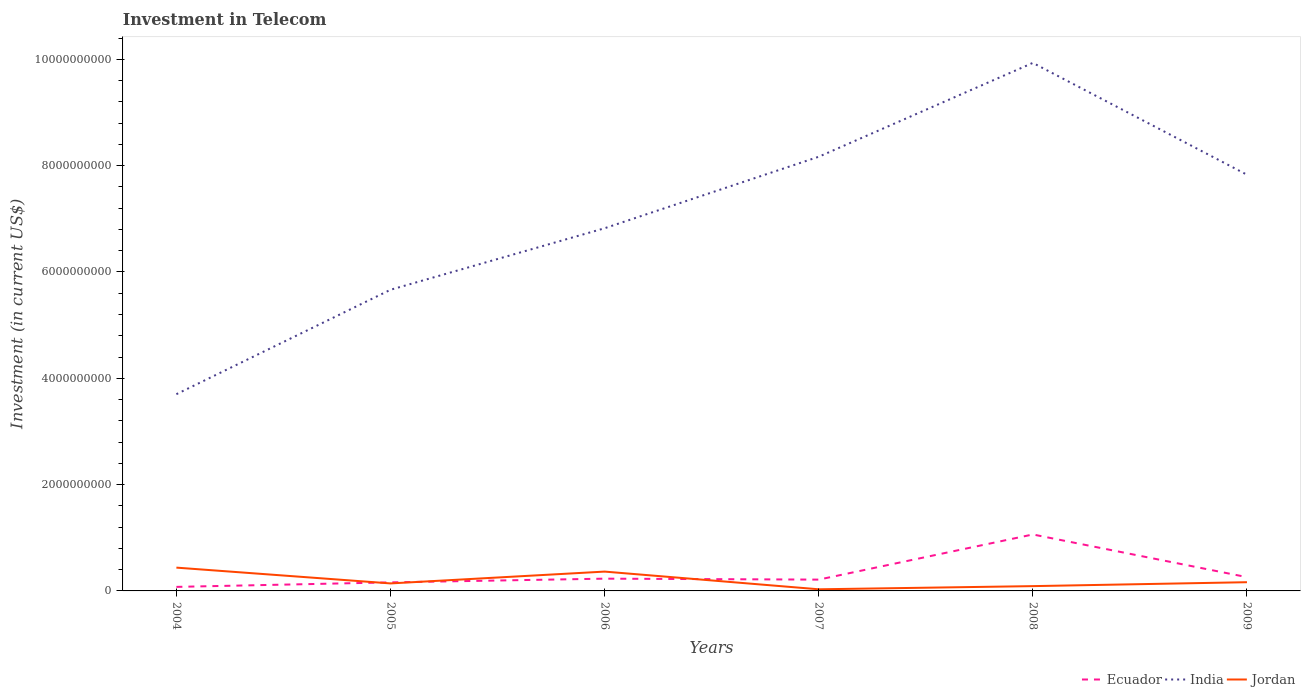How many different coloured lines are there?
Your response must be concise. 3. Is the number of lines equal to the number of legend labels?
Your answer should be very brief. Yes. Across all years, what is the maximum amount invested in telecom in Ecuador?
Make the answer very short. 7.59e+07. What is the total amount invested in telecom in Jordan in the graph?
Give a very brief answer. -7.37e+07. What is the difference between the highest and the second highest amount invested in telecom in India?
Give a very brief answer. 6.23e+09. What is the difference between the highest and the lowest amount invested in telecom in India?
Offer a very short reply. 3. How many lines are there?
Your answer should be very brief. 3. Does the graph contain any zero values?
Your response must be concise. No. How many legend labels are there?
Make the answer very short. 3. How are the legend labels stacked?
Provide a succinct answer. Horizontal. What is the title of the graph?
Offer a terse response. Investment in Telecom. What is the label or title of the X-axis?
Your answer should be compact. Years. What is the label or title of the Y-axis?
Your answer should be compact. Investment (in current US$). What is the Investment (in current US$) in Ecuador in 2004?
Offer a terse response. 7.59e+07. What is the Investment (in current US$) in India in 2004?
Your response must be concise. 3.70e+09. What is the Investment (in current US$) of Jordan in 2004?
Keep it short and to the point. 4.38e+08. What is the Investment (in current US$) of Ecuador in 2005?
Ensure brevity in your answer.  1.61e+08. What is the Investment (in current US$) in India in 2005?
Your response must be concise. 5.67e+09. What is the Investment (in current US$) of Jordan in 2005?
Make the answer very short. 1.41e+08. What is the Investment (in current US$) of Ecuador in 2006?
Offer a terse response. 2.31e+08. What is the Investment (in current US$) in India in 2006?
Ensure brevity in your answer.  6.82e+09. What is the Investment (in current US$) of Jordan in 2006?
Offer a very short reply. 3.64e+08. What is the Investment (in current US$) of Ecuador in 2007?
Your answer should be compact. 2.13e+08. What is the Investment (in current US$) in India in 2007?
Your answer should be very brief. 8.17e+09. What is the Investment (in current US$) of Jordan in 2007?
Make the answer very short. 3.07e+07. What is the Investment (in current US$) in Ecuador in 2008?
Ensure brevity in your answer.  1.06e+09. What is the Investment (in current US$) of India in 2008?
Offer a very short reply. 9.93e+09. What is the Investment (in current US$) of Jordan in 2008?
Provide a succinct answer. 9.03e+07. What is the Investment (in current US$) of Ecuador in 2009?
Keep it short and to the point. 2.59e+08. What is the Investment (in current US$) of India in 2009?
Provide a short and direct response. 7.83e+09. What is the Investment (in current US$) of Jordan in 2009?
Provide a succinct answer. 1.64e+08. Across all years, what is the maximum Investment (in current US$) in Ecuador?
Your answer should be compact. 1.06e+09. Across all years, what is the maximum Investment (in current US$) in India?
Keep it short and to the point. 9.93e+09. Across all years, what is the maximum Investment (in current US$) of Jordan?
Give a very brief answer. 4.38e+08. Across all years, what is the minimum Investment (in current US$) of Ecuador?
Keep it short and to the point. 7.59e+07. Across all years, what is the minimum Investment (in current US$) of India?
Provide a short and direct response. 3.70e+09. Across all years, what is the minimum Investment (in current US$) in Jordan?
Offer a terse response. 3.07e+07. What is the total Investment (in current US$) of Ecuador in the graph?
Your answer should be very brief. 2.00e+09. What is the total Investment (in current US$) of India in the graph?
Offer a very short reply. 4.21e+1. What is the total Investment (in current US$) of Jordan in the graph?
Provide a succinct answer. 1.23e+09. What is the difference between the Investment (in current US$) of Ecuador in 2004 and that in 2005?
Give a very brief answer. -8.49e+07. What is the difference between the Investment (in current US$) in India in 2004 and that in 2005?
Make the answer very short. -1.96e+09. What is the difference between the Investment (in current US$) in Jordan in 2004 and that in 2005?
Your answer should be very brief. 2.97e+08. What is the difference between the Investment (in current US$) of Ecuador in 2004 and that in 2006?
Give a very brief answer. -1.55e+08. What is the difference between the Investment (in current US$) of India in 2004 and that in 2006?
Offer a very short reply. -3.12e+09. What is the difference between the Investment (in current US$) in Jordan in 2004 and that in 2006?
Offer a very short reply. 7.47e+07. What is the difference between the Investment (in current US$) in Ecuador in 2004 and that in 2007?
Your answer should be compact. -1.37e+08. What is the difference between the Investment (in current US$) in India in 2004 and that in 2007?
Your answer should be compact. -4.47e+09. What is the difference between the Investment (in current US$) in Jordan in 2004 and that in 2007?
Your response must be concise. 4.08e+08. What is the difference between the Investment (in current US$) of Ecuador in 2004 and that in 2008?
Your response must be concise. -9.86e+08. What is the difference between the Investment (in current US$) in India in 2004 and that in 2008?
Your response must be concise. -6.23e+09. What is the difference between the Investment (in current US$) of Jordan in 2004 and that in 2008?
Provide a short and direct response. 3.48e+08. What is the difference between the Investment (in current US$) in Ecuador in 2004 and that in 2009?
Ensure brevity in your answer.  -1.83e+08. What is the difference between the Investment (in current US$) in India in 2004 and that in 2009?
Make the answer very short. -4.13e+09. What is the difference between the Investment (in current US$) of Jordan in 2004 and that in 2009?
Provide a succinct answer. 2.74e+08. What is the difference between the Investment (in current US$) in Ecuador in 2005 and that in 2006?
Ensure brevity in your answer.  -7.00e+07. What is the difference between the Investment (in current US$) of India in 2005 and that in 2006?
Your response must be concise. -1.16e+09. What is the difference between the Investment (in current US$) of Jordan in 2005 and that in 2006?
Give a very brief answer. -2.23e+08. What is the difference between the Investment (in current US$) in Ecuador in 2005 and that in 2007?
Give a very brief answer. -5.19e+07. What is the difference between the Investment (in current US$) in India in 2005 and that in 2007?
Give a very brief answer. -2.50e+09. What is the difference between the Investment (in current US$) in Jordan in 2005 and that in 2007?
Your answer should be very brief. 1.10e+08. What is the difference between the Investment (in current US$) in Ecuador in 2005 and that in 2008?
Provide a short and direct response. -9.01e+08. What is the difference between the Investment (in current US$) of India in 2005 and that in 2008?
Offer a terse response. -4.27e+09. What is the difference between the Investment (in current US$) in Jordan in 2005 and that in 2008?
Offer a terse response. 5.07e+07. What is the difference between the Investment (in current US$) in Ecuador in 2005 and that in 2009?
Offer a very short reply. -9.83e+07. What is the difference between the Investment (in current US$) of India in 2005 and that in 2009?
Your answer should be very brief. -2.16e+09. What is the difference between the Investment (in current US$) of Jordan in 2005 and that in 2009?
Give a very brief answer. -2.30e+07. What is the difference between the Investment (in current US$) of Ecuador in 2006 and that in 2007?
Provide a short and direct response. 1.81e+07. What is the difference between the Investment (in current US$) of India in 2006 and that in 2007?
Keep it short and to the point. -1.35e+09. What is the difference between the Investment (in current US$) of Jordan in 2006 and that in 2007?
Provide a short and direct response. 3.33e+08. What is the difference between the Investment (in current US$) in Ecuador in 2006 and that in 2008?
Make the answer very short. -8.31e+08. What is the difference between the Investment (in current US$) of India in 2006 and that in 2008?
Provide a short and direct response. -3.11e+09. What is the difference between the Investment (in current US$) in Jordan in 2006 and that in 2008?
Your answer should be compact. 2.73e+08. What is the difference between the Investment (in current US$) in Ecuador in 2006 and that in 2009?
Provide a succinct answer. -2.83e+07. What is the difference between the Investment (in current US$) in India in 2006 and that in 2009?
Your answer should be compact. -1.01e+09. What is the difference between the Investment (in current US$) of Jordan in 2006 and that in 2009?
Offer a very short reply. 2.00e+08. What is the difference between the Investment (in current US$) of Ecuador in 2007 and that in 2008?
Your answer should be very brief. -8.49e+08. What is the difference between the Investment (in current US$) of India in 2007 and that in 2008?
Offer a very short reply. -1.77e+09. What is the difference between the Investment (in current US$) of Jordan in 2007 and that in 2008?
Offer a very short reply. -5.96e+07. What is the difference between the Investment (in current US$) in Ecuador in 2007 and that in 2009?
Ensure brevity in your answer.  -4.64e+07. What is the difference between the Investment (in current US$) in India in 2007 and that in 2009?
Ensure brevity in your answer.  3.38e+08. What is the difference between the Investment (in current US$) in Jordan in 2007 and that in 2009?
Your response must be concise. -1.33e+08. What is the difference between the Investment (in current US$) in Ecuador in 2008 and that in 2009?
Make the answer very short. 8.03e+08. What is the difference between the Investment (in current US$) in India in 2008 and that in 2009?
Offer a very short reply. 2.10e+09. What is the difference between the Investment (in current US$) of Jordan in 2008 and that in 2009?
Make the answer very short. -7.37e+07. What is the difference between the Investment (in current US$) in Ecuador in 2004 and the Investment (in current US$) in India in 2005?
Offer a terse response. -5.59e+09. What is the difference between the Investment (in current US$) of Ecuador in 2004 and the Investment (in current US$) of Jordan in 2005?
Make the answer very short. -6.51e+07. What is the difference between the Investment (in current US$) in India in 2004 and the Investment (in current US$) in Jordan in 2005?
Provide a short and direct response. 3.56e+09. What is the difference between the Investment (in current US$) of Ecuador in 2004 and the Investment (in current US$) of India in 2006?
Your answer should be very brief. -6.75e+09. What is the difference between the Investment (in current US$) of Ecuador in 2004 and the Investment (in current US$) of Jordan in 2006?
Keep it short and to the point. -2.88e+08. What is the difference between the Investment (in current US$) in India in 2004 and the Investment (in current US$) in Jordan in 2006?
Provide a succinct answer. 3.34e+09. What is the difference between the Investment (in current US$) of Ecuador in 2004 and the Investment (in current US$) of India in 2007?
Make the answer very short. -8.09e+09. What is the difference between the Investment (in current US$) of Ecuador in 2004 and the Investment (in current US$) of Jordan in 2007?
Your response must be concise. 4.52e+07. What is the difference between the Investment (in current US$) of India in 2004 and the Investment (in current US$) of Jordan in 2007?
Ensure brevity in your answer.  3.67e+09. What is the difference between the Investment (in current US$) of Ecuador in 2004 and the Investment (in current US$) of India in 2008?
Your answer should be very brief. -9.86e+09. What is the difference between the Investment (in current US$) in Ecuador in 2004 and the Investment (in current US$) in Jordan in 2008?
Provide a short and direct response. -1.44e+07. What is the difference between the Investment (in current US$) in India in 2004 and the Investment (in current US$) in Jordan in 2008?
Keep it short and to the point. 3.61e+09. What is the difference between the Investment (in current US$) in Ecuador in 2004 and the Investment (in current US$) in India in 2009?
Provide a succinct answer. -7.75e+09. What is the difference between the Investment (in current US$) in Ecuador in 2004 and the Investment (in current US$) in Jordan in 2009?
Your response must be concise. -8.81e+07. What is the difference between the Investment (in current US$) of India in 2004 and the Investment (in current US$) of Jordan in 2009?
Your answer should be very brief. 3.54e+09. What is the difference between the Investment (in current US$) in Ecuador in 2005 and the Investment (in current US$) in India in 2006?
Offer a terse response. -6.66e+09. What is the difference between the Investment (in current US$) in Ecuador in 2005 and the Investment (in current US$) in Jordan in 2006?
Provide a short and direct response. -2.03e+08. What is the difference between the Investment (in current US$) of India in 2005 and the Investment (in current US$) of Jordan in 2006?
Provide a succinct answer. 5.30e+09. What is the difference between the Investment (in current US$) of Ecuador in 2005 and the Investment (in current US$) of India in 2007?
Provide a succinct answer. -8.01e+09. What is the difference between the Investment (in current US$) in Ecuador in 2005 and the Investment (in current US$) in Jordan in 2007?
Ensure brevity in your answer.  1.30e+08. What is the difference between the Investment (in current US$) of India in 2005 and the Investment (in current US$) of Jordan in 2007?
Ensure brevity in your answer.  5.64e+09. What is the difference between the Investment (in current US$) in Ecuador in 2005 and the Investment (in current US$) in India in 2008?
Offer a very short reply. -9.77e+09. What is the difference between the Investment (in current US$) in Ecuador in 2005 and the Investment (in current US$) in Jordan in 2008?
Make the answer very short. 7.05e+07. What is the difference between the Investment (in current US$) in India in 2005 and the Investment (in current US$) in Jordan in 2008?
Provide a short and direct response. 5.58e+09. What is the difference between the Investment (in current US$) of Ecuador in 2005 and the Investment (in current US$) of India in 2009?
Provide a short and direct response. -7.67e+09. What is the difference between the Investment (in current US$) of Ecuador in 2005 and the Investment (in current US$) of Jordan in 2009?
Offer a terse response. -3.20e+06. What is the difference between the Investment (in current US$) in India in 2005 and the Investment (in current US$) in Jordan in 2009?
Offer a very short reply. 5.50e+09. What is the difference between the Investment (in current US$) in Ecuador in 2006 and the Investment (in current US$) in India in 2007?
Provide a succinct answer. -7.94e+09. What is the difference between the Investment (in current US$) of Ecuador in 2006 and the Investment (in current US$) of Jordan in 2007?
Your answer should be compact. 2.00e+08. What is the difference between the Investment (in current US$) in India in 2006 and the Investment (in current US$) in Jordan in 2007?
Your answer should be very brief. 6.79e+09. What is the difference between the Investment (in current US$) in Ecuador in 2006 and the Investment (in current US$) in India in 2008?
Give a very brief answer. -9.70e+09. What is the difference between the Investment (in current US$) in Ecuador in 2006 and the Investment (in current US$) in Jordan in 2008?
Provide a short and direct response. 1.40e+08. What is the difference between the Investment (in current US$) of India in 2006 and the Investment (in current US$) of Jordan in 2008?
Your answer should be compact. 6.73e+09. What is the difference between the Investment (in current US$) of Ecuador in 2006 and the Investment (in current US$) of India in 2009?
Provide a succinct answer. -7.60e+09. What is the difference between the Investment (in current US$) of Ecuador in 2006 and the Investment (in current US$) of Jordan in 2009?
Your response must be concise. 6.68e+07. What is the difference between the Investment (in current US$) of India in 2006 and the Investment (in current US$) of Jordan in 2009?
Give a very brief answer. 6.66e+09. What is the difference between the Investment (in current US$) of Ecuador in 2007 and the Investment (in current US$) of India in 2008?
Offer a very short reply. -9.72e+09. What is the difference between the Investment (in current US$) of Ecuador in 2007 and the Investment (in current US$) of Jordan in 2008?
Offer a very short reply. 1.22e+08. What is the difference between the Investment (in current US$) of India in 2007 and the Investment (in current US$) of Jordan in 2008?
Your answer should be very brief. 8.08e+09. What is the difference between the Investment (in current US$) in Ecuador in 2007 and the Investment (in current US$) in India in 2009?
Your answer should be very brief. -7.62e+09. What is the difference between the Investment (in current US$) of Ecuador in 2007 and the Investment (in current US$) of Jordan in 2009?
Give a very brief answer. 4.87e+07. What is the difference between the Investment (in current US$) of India in 2007 and the Investment (in current US$) of Jordan in 2009?
Offer a terse response. 8.00e+09. What is the difference between the Investment (in current US$) in Ecuador in 2008 and the Investment (in current US$) in India in 2009?
Provide a short and direct response. -6.77e+09. What is the difference between the Investment (in current US$) in Ecuador in 2008 and the Investment (in current US$) in Jordan in 2009?
Provide a succinct answer. 8.98e+08. What is the difference between the Investment (in current US$) of India in 2008 and the Investment (in current US$) of Jordan in 2009?
Keep it short and to the point. 9.77e+09. What is the average Investment (in current US$) in Ecuador per year?
Keep it short and to the point. 3.34e+08. What is the average Investment (in current US$) in India per year?
Your response must be concise. 7.02e+09. What is the average Investment (in current US$) of Jordan per year?
Offer a terse response. 2.05e+08. In the year 2004, what is the difference between the Investment (in current US$) in Ecuador and Investment (in current US$) in India?
Provide a short and direct response. -3.63e+09. In the year 2004, what is the difference between the Investment (in current US$) in Ecuador and Investment (in current US$) in Jordan?
Offer a terse response. -3.62e+08. In the year 2004, what is the difference between the Investment (in current US$) of India and Investment (in current US$) of Jordan?
Your response must be concise. 3.26e+09. In the year 2005, what is the difference between the Investment (in current US$) of Ecuador and Investment (in current US$) of India?
Keep it short and to the point. -5.50e+09. In the year 2005, what is the difference between the Investment (in current US$) of Ecuador and Investment (in current US$) of Jordan?
Provide a short and direct response. 1.98e+07. In the year 2005, what is the difference between the Investment (in current US$) in India and Investment (in current US$) in Jordan?
Provide a succinct answer. 5.52e+09. In the year 2006, what is the difference between the Investment (in current US$) in Ecuador and Investment (in current US$) in India?
Ensure brevity in your answer.  -6.59e+09. In the year 2006, what is the difference between the Investment (in current US$) of Ecuador and Investment (in current US$) of Jordan?
Ensure brevity in your answer.  -1.33e+08. In the year 2006, what is the difference between the Investment (in current US$) of India and Investment (in current US$) of Jordan?
Keep it short and to the point. 6.46e+09. In the year 2007, what is the difference between the Investment (in current US$) in Ecuador and Investment (in current US$) in India?
Your answer should be very brief. -7.96e+09. In the year 2007, what is the difference between the Investment (in current US$) in Ecuador and Investment (in current US$) in Jordan?
Offer a terse response. 1.82e+08. In the year 2007, what is the difference between the Investment (in current US$) in India and Investment (in current US$) in Jordan?
Offer a very short reply. 8.14e+09. In the year 2008, what is the difference between the Investment (in current US$) in Ecuador and Investment (in current US$) in India?
Offer a terse response. -8.87e+09. In the year 2008, what is the difference between the Investment (in current US$) of Ecuador and Investment (in current US$) of Jordan?
Your response must be concise. 9.72e+08. In the year 2008, what is the difference between the Investment (in current US$) in India and Investment (in current US$) in Jordan?
Keep it short and to the point. 9.84e+09. In the year 2009, what is the difference between the Investment (in current US$) in Ecuador and Investment (in current US$) in India?
Offer a very short reply. -7.57e+09. In the year 2009, what is the difference between the Investment (in current US$) in Ecuador and Investment (in current US$) in Jordan?
Offer a terse response. 9.51e+07. In the year 2009, what is the difference between the Investment (in current US$) of India and Investment (in current US$) of Jordan?
Ensure brevity in your answer.  7.67e+09. What is the ratio of the Investment (in current US$) of Ecuador in 2004 to that in 2005?
Provide a succinct answer. 0.47. What is the ratio of the Investment (in current US$) of India in 2004 to that in 2005?
Ensure brevity in your answer.  0.65. What is the ratio of the Investment (in current US$) of Jordan in 2004 to that in 2005?
Provide a succinct answer. 3.11. What is the ratio of the Investment (in current US$) in Ecuador in 2004 to that in 2006?
Provide a short and direct response. 0.33. What is the ratio of the Investment (in current US$) in India in 2004 to that in 2006?
Offer a terse response. 0.54. What is the ratio of the Investment (in current US$) in Jordan in 2004 to that in 2006?
Your answer should be very brief. 1.21. What is the ratio of the Investment (in current US$) of Ecuador in 2004 to that in 2007?
Keep it short and to the point. 0.36. What is the ratio of the Investment (in current US$) in India in 2004 to that in 2007?
Your answer should be compact. 0.45. What is the ratio of the Investment (in current US$) of Jordan in 2004 to that in 2007?
Provide a short and direct response. 14.28. What is the ratio of the Investment (in current US$) of Ecuador in 2004 to that in 2008?
Keep it short and to the point. 0.07. What is the ratio of the Investment (in current US$) of India in 2004 to that in 2008?
Give a very brief answer. 0.37. What is the ratio of the Investment (in current US$) in Jordan in 2004 to that in 2008?
Your answer should be very brief. 4.85. What is the ratio of the Investment (in current US$) in Ecuador in 2004 to that in 2009?
Offer a terse response. 0.29. What is the ratio of the Investment (in current US$) in India in 2004 to that in 2009?
Offer a terse response. 0.47. What is the ratio of the Investment (in current US$) of Jordan in 2004 to that in 2009?
Give a very brief answer. 2.67. What is the ratio of the Investment (in current US$) in Ecuador in 2005 to that in 2006?
Make the answer very short. 0.7. What is the ratio of the Investment (in current US$) in India in 2005 to that in 2006?
Make the answer very short. 0.83. What is the ratio of the Investment (in current US$) of Jordan in 2005 to that in 2006?
Your answer should be compact. 0.39. What is the ratio of the Investment (in current US$) of Ecuador in 2005 to that in 2007?
Give a very brief answer. 0.76. What is the ratio of the Investment (in current US$) in India in 2005 to that in 2007?
Provide a succinct answer. 0.69. What is the ratio of the Investment (in current US$) in Jordan in 2005 to that in 2007?
Give a very brief answer. 4.59. What is the ratio of the Investment (in current US$) in Ecuador in 2005 to that in 2008?
Ensure brevity in your answer.  0.15. What is the ratio of the Investment (in current US$) of India in 2005 to that in 2008?
Provide a short and direct response. 0.57. What is the ratio of the Investment (in current US$) of Jordan in 2005 to that in 2008?
Keep it short and to the point. 1.56. What is the ratio of the Investment (in current US$) of Ecuador in 2005 to that in 2009?
Your answer should be very brief. 0.62. What is the ratio of the Investment (in current US$) of India in 2005 to that in 2009?
Offer a very short reply. 0.72. What is the ratio of the Investment (in current US$) of Jordan in 2005 to that in 2009?
Your answer should be very brief. 0.86. What is the ratio of the Investment (in current US$) in Ecuador in 2006 to that in 2007?
Your answer should be very brief. 1.09. What is the ratio of the Investment (in current US$) in India in 2006 to that in 2007?
Provide a short and direct response. 0.84. What is the ratio of the Investment (in current US$) of Jordan in 2006 to that in 2007?
Provide a short and direct response. 11.84. What is the ratio of the Investment (in current US$) in Ecuador in 2006 to that in 2008?
Provide a succinct answer. 0.22. What is the ratio of the Investment (in current US$) of India in 2006 to that in 2008?
Your answer should be compact. 0.69. What is the ratio of the Investment (in current US$) in Jordan in 2006 to that in 2008?
Give a very brief answer. 4.03. What is the ratio of the Investment (in current US$) of Ecuador in 2006 to that in 2009?
Your answer should be very brief. 0.89. What is the ratio of the Investment (in current US$) in India in 2006 to that in 2009?
Offer a very short reply. 0.87. What is the ratio of the Investment (in current US$) in Jordan in 2006 to that in 2009?
Provide a short and direct response. 2.22. What is the ratio of the Investment (in current US$) of Ecuador in 2007 to that in 2008?
Your answer should be compact. 0.2. What is the ratio of the Investment (in current US$) of India in 2007 to that in 2008?
Keep it short and to the point. 0.82. What is the ratio of the Investment (in current US$) of Jordan in 2007 to that in 2008?
Ensure brevity in your answer.  0.34. What is the ratio of the Investment (in current US$) of Ecuador in 2007 to that in 2009?
Offer a very short reply. 0.82. What is the ratio of the Investment (in current US$) of India in 2007 to that in 2009?
Your response must be concise. 1.04. What is the ratio of the Investment (in current US$) in Jordan in 2007 to that in 2009?
Provide a succinct answer. 0.19. What is the ratio of the Investment (in current US$) of Ecuador in 2008 to that in 2009?
Provide a succinct answer. 4.1. What is the ratio of the Investment (in current US$) of India in 2008 to that in 2009?
Provide a succinct answer. 1.27. What is the ratio of the Investment (in current US$) of Jordan in 2008 to that in 2009?
Give a very brief answer. 0.55. What is the difference between the highest and the second highest Investment (in current US$) of Ecuador?
Provide a short and direct response. 8.03e+08. What is the difference between the highest and the second highest Investment (in current US$) in India?
Offer a terse response. 1.77e+09. What is the difference between the highest and the second highest Investment (in current US$) of Jordan?
Your response must be concise. 7.47e+07. What is the difference between the highest and the lowest Investment (in current US$) of Ecuador?
Your answer should be compact. 9.86e+08. What is the difference between the highest and the lowest Investment (in current US$) of India?
Provide a short and direct response. 6.23e+09. What is the difference between the highest and the lowest Investment (in current US$) in Jordan?
Provide a succinct answer. 4.08e+08. 